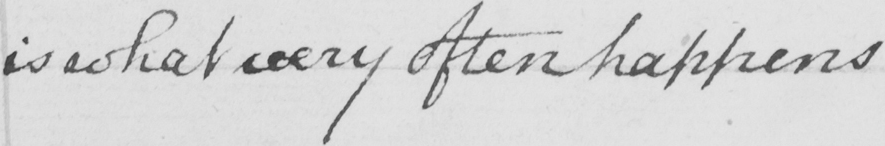Can you tell me what this handwritten text says? is what very often happens 